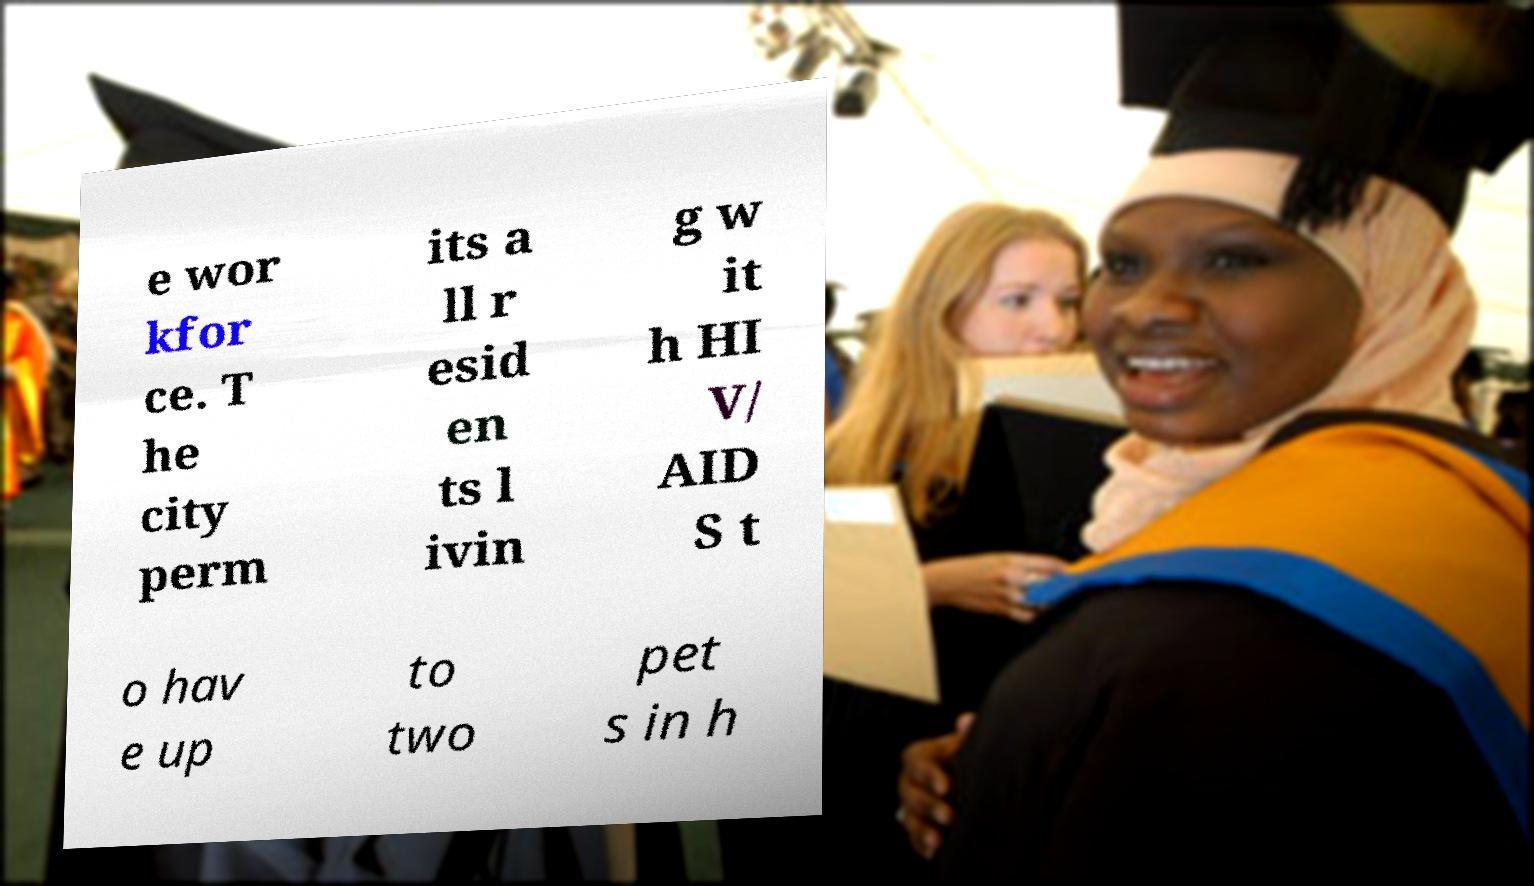Can you read and provide the text displayed in the image?This photo seems to have some interesting text. Can you extract and type it out for me? e wor kfor ce. T he city perm its a ll r esid en ts l ivin g w it h HI V/ AID S t o hav e up to two pet s in h 